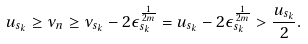<formula> <loc_0><loc_0><loc_500><loc_500>u _ { s _ { k } } \geq \nu _ { n } \geq \nu _ { s _ { k } } - 2 \epsilon _ { s _ { k } } ^ { \frac { 1 } { 2 m } } = u _ { s _ { k } } - 2 \epsilon _ { s _ { k } } ^ { \frac { 1 } { 2 m } } > \frac { u _ { s _ { k } } } { 2 } .</formula> 